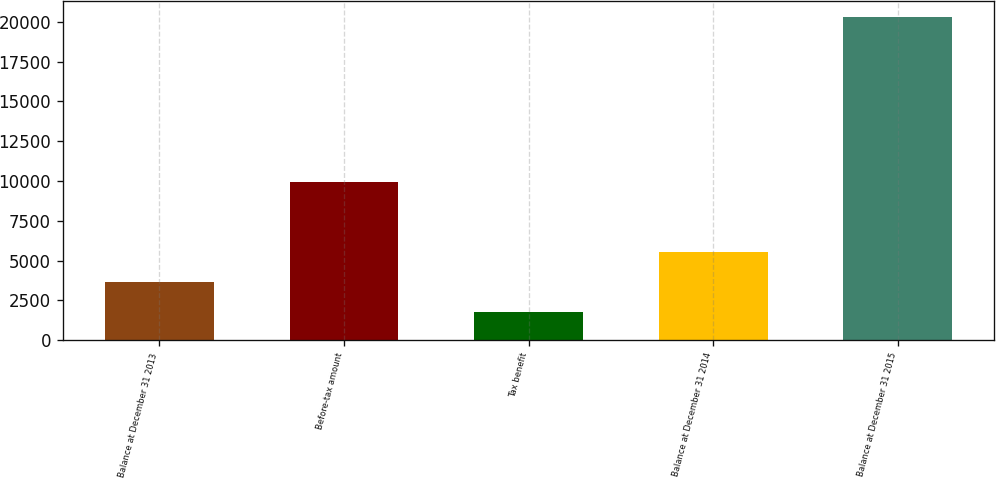<chart> <loc_0><loc_0><loc_500><loc_500><bar_chart><fcel>Balance at December 31 2013<fcel>Before-tax amount<fcel>Tax benefit<fcel>Balance at December 31 2014<fcel>Balance at December 31 2015<nl><fcel>3640.1<fcel>9934<fcel>1792<fcel>5513<fcel>20273<nl></chart> 